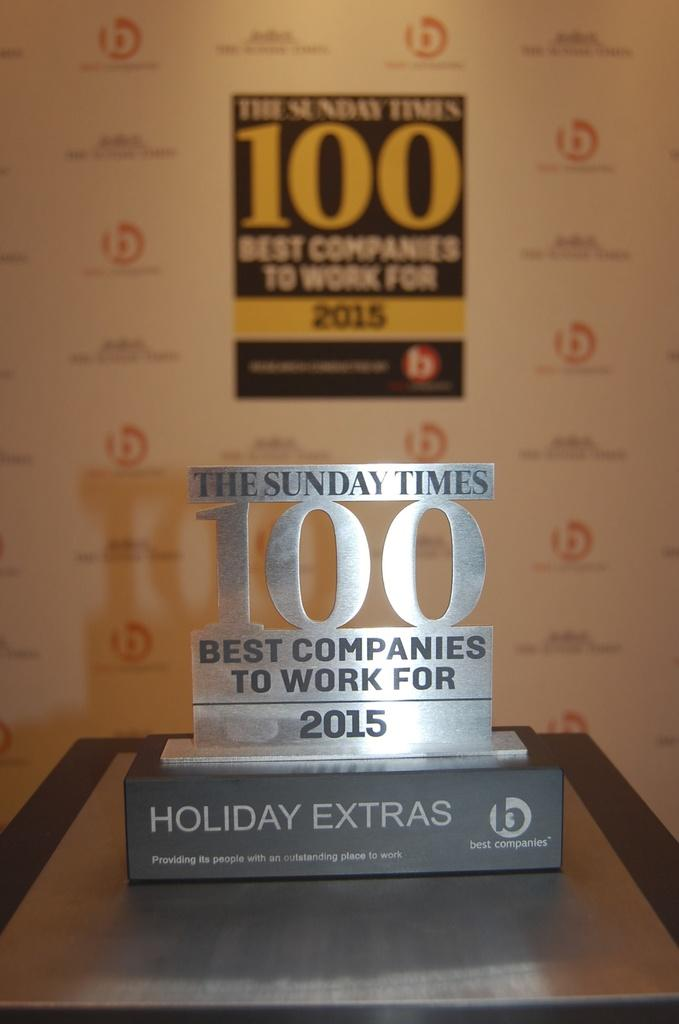<image>
Write a terse but informative summary of the picture. An award announces that The Sunday Times is one of the best places to work in 2015. 